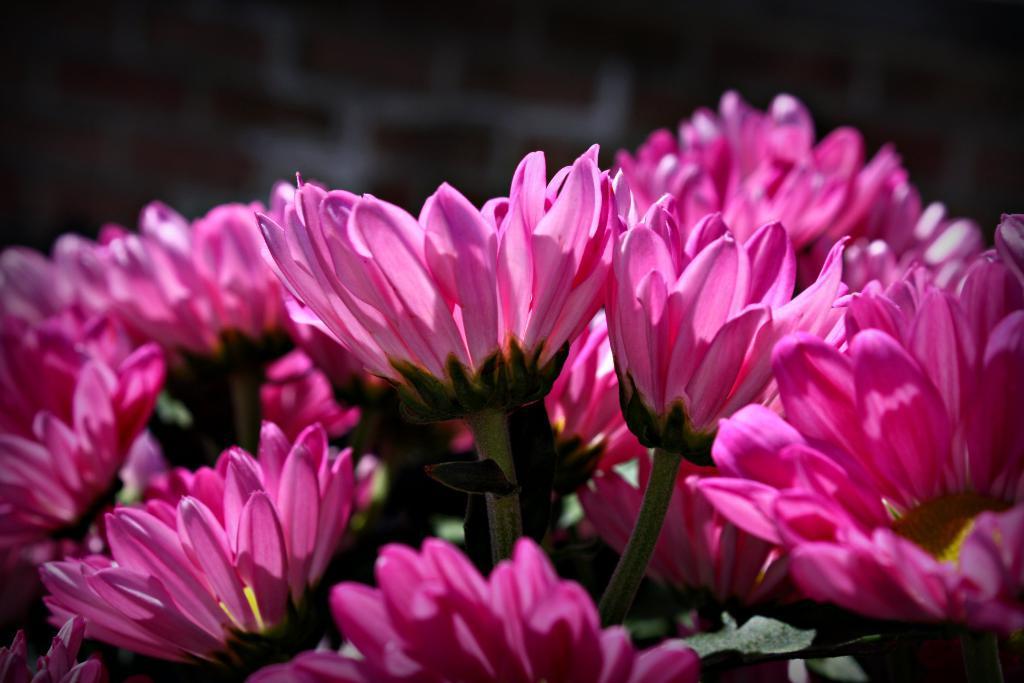How would you summarize this image in a sentence or two? Here we can see pink flowers. Background it is dark. 